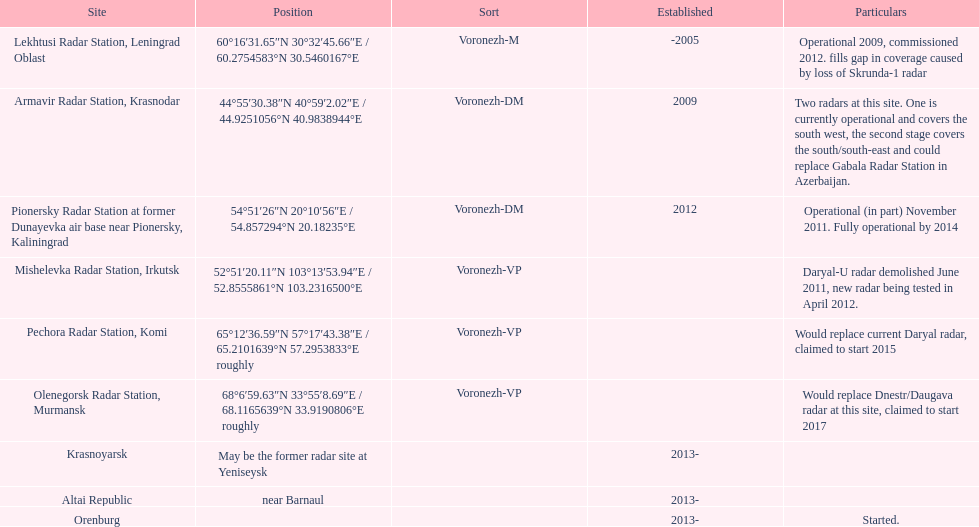What is the only spot having coordinates 60°16'3 Lekhtusi Radar Station, Leningrad Oblast. 